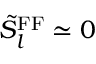<formula> <loc_0><loc_0><loc_500><loc_500>\tilde { S } _ { l } ^ { F F } \simeq 0</formula> 